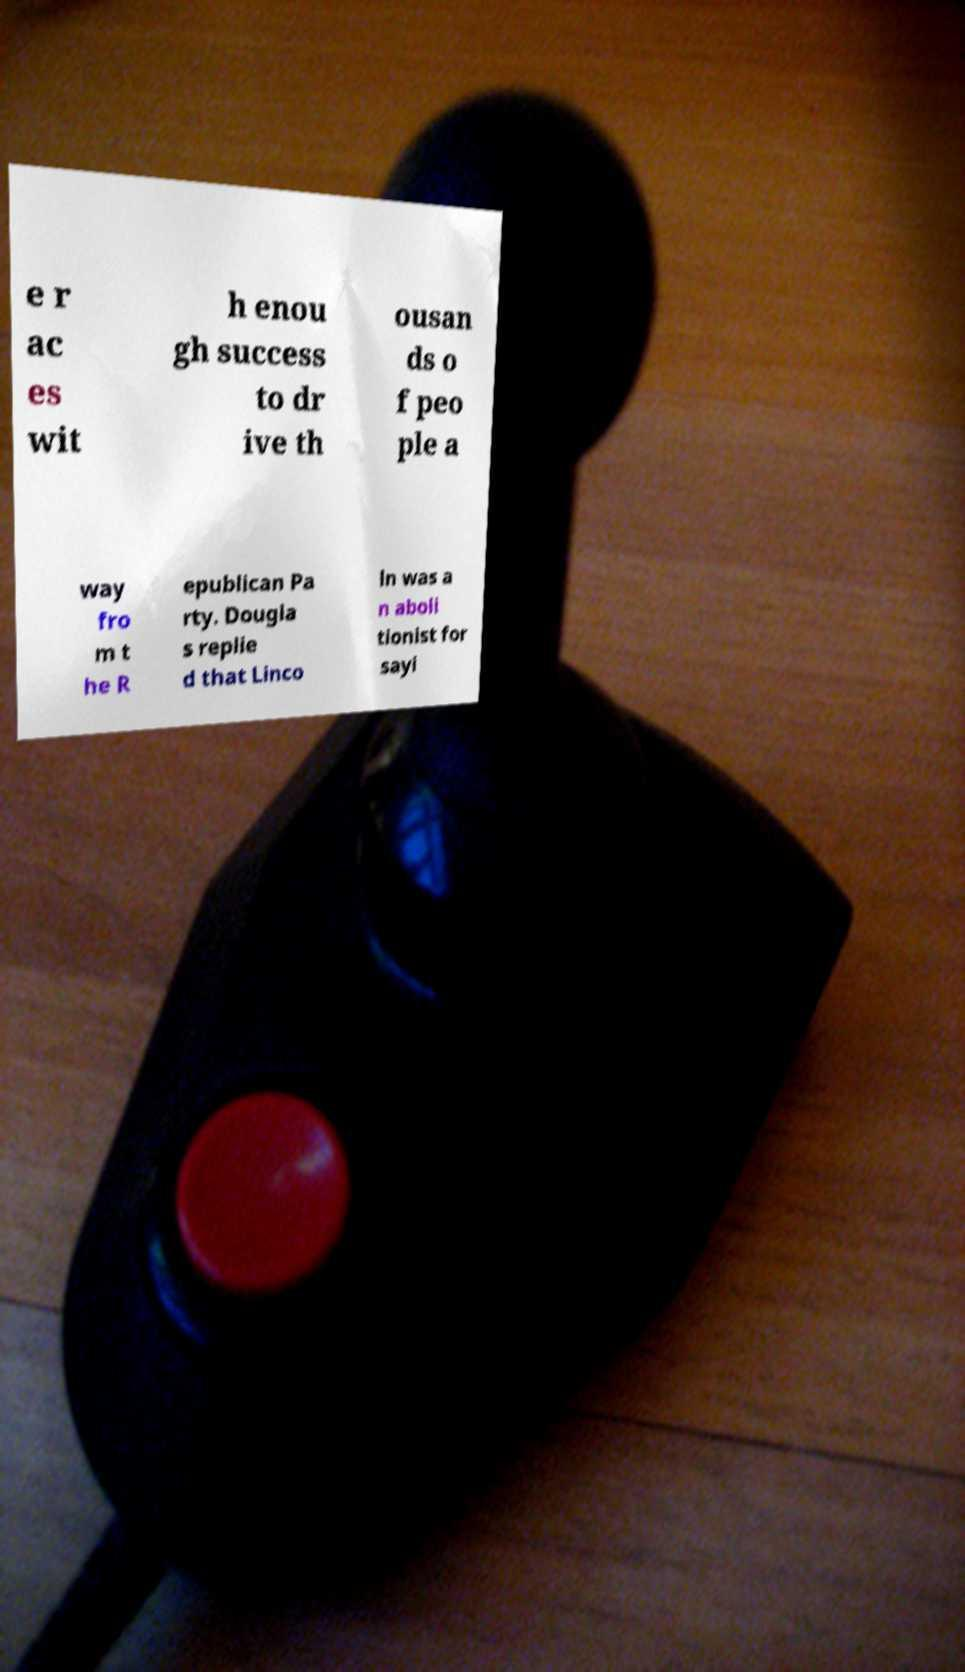Can you accurately transcribe the text from the provided image for me? e r ac es wit h enou gh success to dr ive th ousan ds o f peo ple a way fro m t he R epublican Pa rty. Dougla s replie d that Linco ln was a n aboli tionist for sayi 